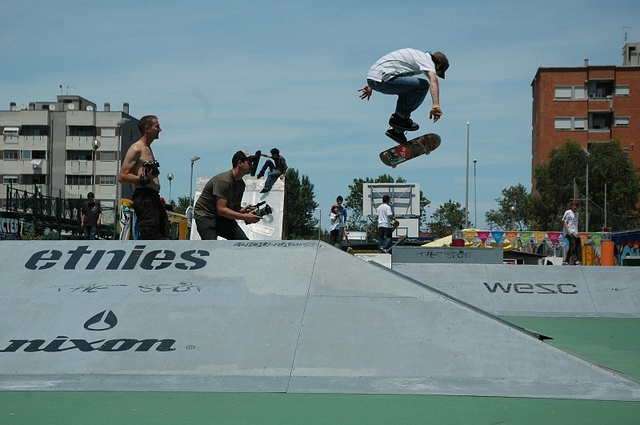Describe the objects in this image and their specific colors. I can see people in gray, black, darkgray, and lightgray tones, people in gray, black, and maroon tones, people in gray, black, and maroon tones, skateboard in gray, black, maroon, and darkgray tones, and people in gray, black, darkgray, and lightgray tones in this image. 